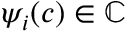<formula> <loc_0><loc_0><loc_500><loc_500>\psi _ { i } ( c ) \in \mathbb { C }</formula> 